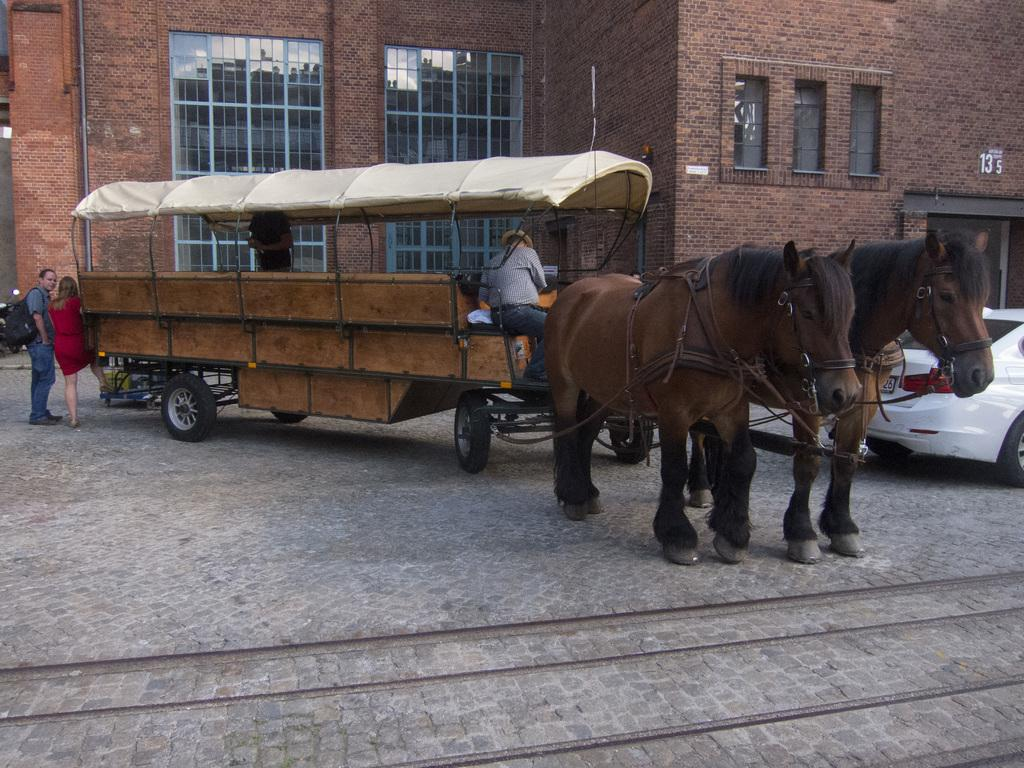What mode of transportation are the people using in the image? The people are using a horse cart as their mode of transportation. What other type of vehicle is visible in the image? There is a car visible in the image. What are the people on the ground doing? The people standing on the ground are not engaged in any specific activity in the image. What can be seen in the background of the image? There is a building with windows in the background. Can you tell me where the aunt is standing in the image? There is no aunt present in the image. What type of work does the slave perform in the image? There is no slave present in the image. 